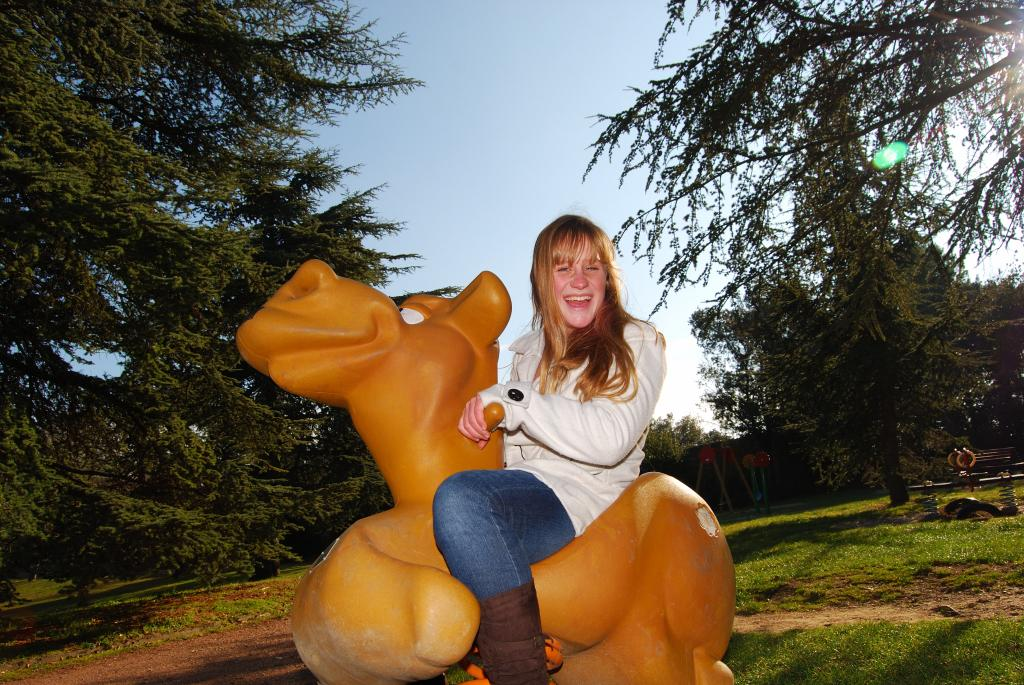What is the person in the image doing? The person is sitting in the image. What is the person sitting on? The person is sitting on a yellow object. What can be seen in the background of the image? There are trees visible in the background. What is the color of the sky in the image? The sky is blue and white in color. What type of finger food is the person eating in the image? There is no finger food present in the image; the person is sitting on a yellow object. 